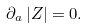Convert formula to latex. <formula><loc_0><loc_0><loc_500><loc_500>\partial _ { a } \, | Z | = 0 .</formula> 